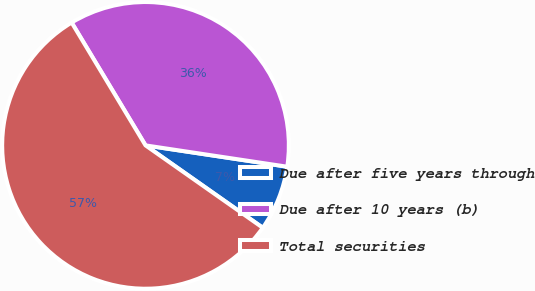Convert chart. <chart><loc_0><loc_0><loc_500><loc_500><pie_chart><fcel>Due after five years through<fcel>Due after 10 years (b)<fcel>Total securities<nl><fcel>7.37%<fcel>36.0%<fcel>56.64%<nl></chart> 